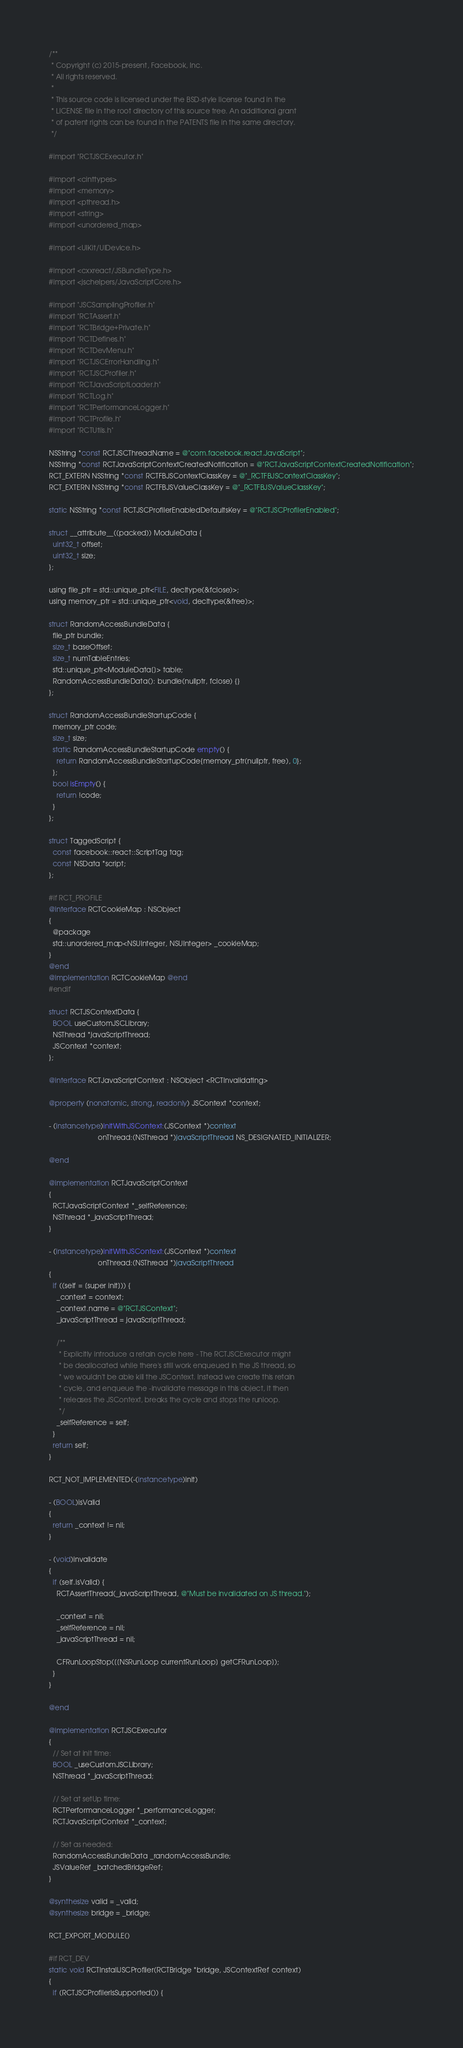Convert code to text. <code><loc_0><loc_0><loc_500><loc_500><_ObjectiveC_>/**
 * Copyright (c) 2015-present, Facebook, Inc.
 * All rights reserved.
 *
 * This source code is licensed under the BSD-style license found in the
 * LICENSE file in the root directory of this source tree. An additional grant
 * of patent rights can be found in the PATENTS file in the same directory.
 */

#import "RCTJSCExecutor.h"

#import <cinttypes>
#import <memory>
#import <pthread.h>
#import <string>
#import <unordered_map>

#import <UIKit/UIDevice.h>

#import <cxxreact/JSBundleType.h>
#import <jschelpers/JavaScriptCore.h>

#import "JSCSamplingProfiler.h"
#import "RCTAssert.h"
#import "RCTBridge+Private.h"
#import "RCTDefines.h"
#import "RCTDevMenu.h"
#import "RCTJSCErrorHandling.h"
#import "RCTJSCProfiler.h"
#import "RCTJavaScriptLoader.h"
#import "RCTLog.h"
#import "RCTPerformanceLogger.h"
#import "RCTProfile.h"
#import "RCTUtils.h"

NSString *const RCTJSCThreadName = @"com.facebook.react.JavaScript";
NSString *const RCTJavaScriptContextCreatedNotification = @"RCTJavaScriptContextCreatedNotification";
RCT_EXTERN NSString *const RCTFBJSContextClassKey = @"_RCTFBJSContextClassKey";
RCT_EXTERN NSString *const RCTFBJSValueClassKey = @"_RCTFBJSValueClassKey";

static NSString *const RCTJSCProfilerEnabledDefaultsKey = @"RCTJSCProfilerEnabled";

struct __attribute__((packed)) ModuleData {
  uint32_t offset;
  uint32_t size;
};

using file_ptr = std::unique_ptr<FILE, decltype(&fclose)>;
using memory_ptr = std::unique_ptr<void, decltype(&free)>;

struct RandomAccessBundleData {
  file_ptr bundle;
  size_t baseOffset;
  size_t numTableEntries;
  std::unique_ptr<ModuleData[]> table;
  RandomAccessBundleData(): bundle(nullptr, fclose) {}
};

struct RandomAccessBundleStartupCode {
  memory_ptr code;
  size_t size;
  static RandomAccessBundleStartupCode empty() {
    return RandomAccessBundleStartupCode{memory_ptr(nullptr, free), 0};
  };
  bool isEmpty() {
    return !code;
  }
};

struct TaggedScript {
  const facebook::react::ScriptTag tag;
  const NSData *script;
};

#if RCT_PROFILE
@interface RCTCookieMap : NSObject
{
  @package
  std::unordered_map<NSUInteger, NSUInteger> _cookieMap;
}
@end
@implementation RCTCookieMap @end
#endif

struct RCTJSContextData {
  BOOL useCustomJSCLibrary;
  NSThread *javaScriptThread;
  JSContext *context;
};

@interface RCTJavaScriptContext : NSObject <RCTInvalidating>

@property (nonatomic, strong, readonly) JSContext *context;

- (instancetype)initWithJSContext:(JSContext *)context
                         onThread:(NSThread *)javaScriptThread NS_DESIGNATED_INITIALIZER;

@end

@implementation RCTJavaScriptContext
{
  RCTJavaScriptContext *_selfReference;
  NSThread *_javaScriptThread;
}

- (instancetype)initWithJSContext:(JSContext *)context
                         onThread:(NSThread *)javaScriptThread
{
  if ((self = [super init])) {
    _context = context;
    _context.name = @"RCTJSContext";
    _javaScriptThread = javaScriptThread;

    /**
     * Explicitly introduce a retain cycle here - The RCTJSCExecutor might
     * be deallocated while there's still work enqueued in the JS thread, so
     * we wouldn't be able kill the JSContext. Instead we create this retain
     * cycle, and enqueue the -invalidate message in this object, it then
     * releases the JSContext, breaks the cycle and stops the runloop.
     */
    _selfReference = self;
  }
  return self;
}

RCT_NOT_IMPLEMENTED(-(instancetype)init)

- (BOOL)isValid
{
  return _context != nil;
}

- (void)invalidate
{
  if (self.isValid) {
    RCTAssertThread(_javaScriptThread, @"Must be invalidated on JS thread.");

    _context = nil;
    _selfReference = nil;
    _javaScriptThread = nil;

    CFRunLoopStop([[NSRunLoop currentRunLoop] getCFRunLoop]);
  }
}

@end

@implementation RCTJSCExecutor
{
  // Set at init time:
  BOOL _useCustomJSCLibrary;
  NSThread *_javaScriptThread;

  // Set at setUp time:
  RCTPerformanceLogger *_performanceLogger;
  RCTJavaScriptContext *_context;

  // Set as needed:
  RandomAccessBundleData _randomAccessBundle;
  JSValueRef _batchedBridgeRef;
}

@synthesize valid = _valid;
@synthesize bridge = _bridge;

RCT_EXPORT_MODULE()

#if RCT_DEV
static void RCTInstallJSCProfiler(RCTBridge *bridge, JSContextRef context)
{
  if (RCTJSCProfilerIsSupported()) {</code> 